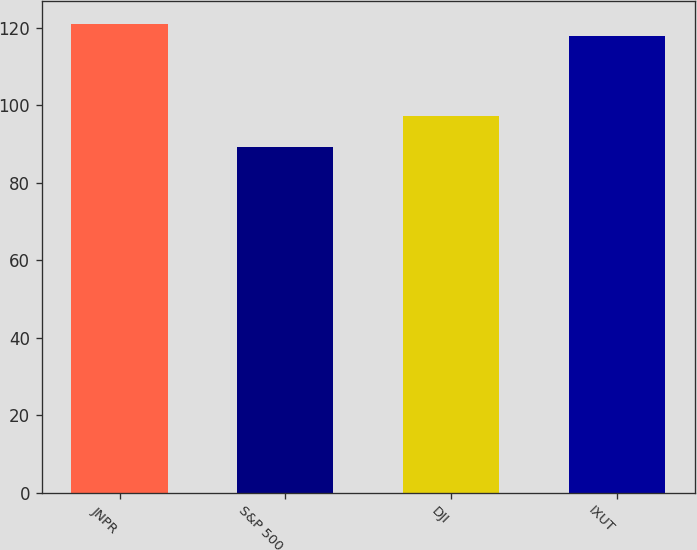Convert chart. <chart><loc_0><loc_0><loc_500><loc_500><bar_chart><fcel>JNPR<fcel>S&P 500<fcel>DJI<fcel>IXUT<nl><fcel>120.92<fcel>89.33<fcel>97.3<fcel>117.89<nl></chart> 